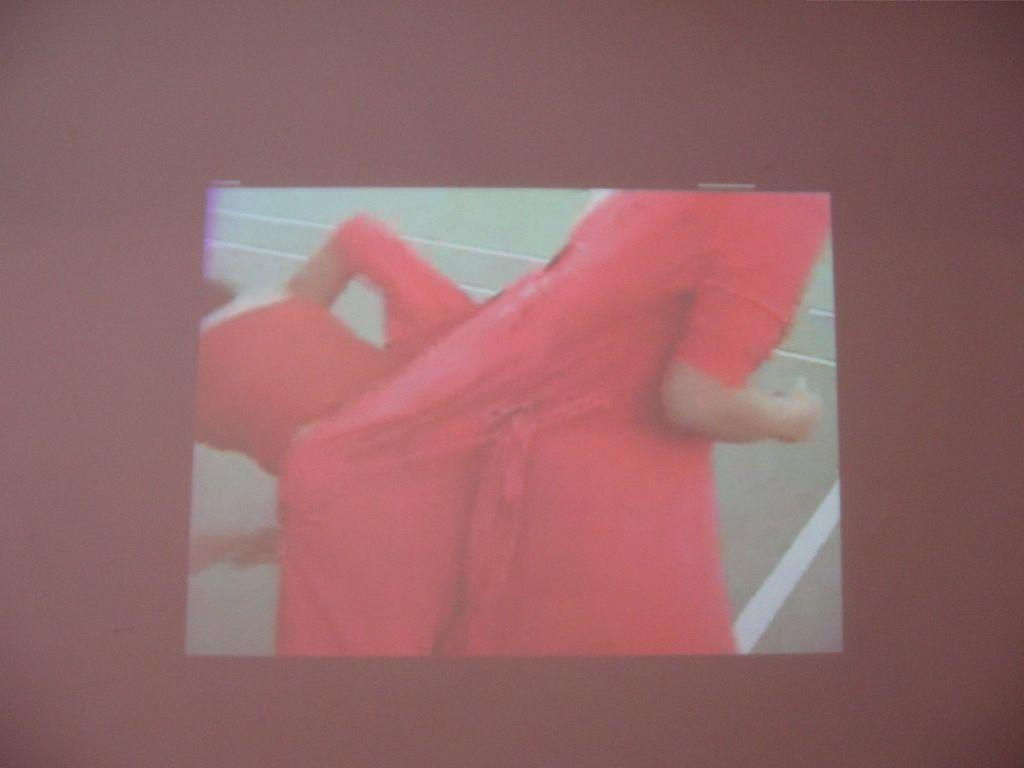What is the main subject in the middle of the image? There is a screen in the middle of the image. What is depicted on the screen? Two persons are standing on the ground on the screen. What color is the background of the screen? The background of the screen is in black color. What type of glass is being used to show respect in the image? There is no glass or indication of respect in the image; it features a screen with two persons standing on the ground against a black background. 